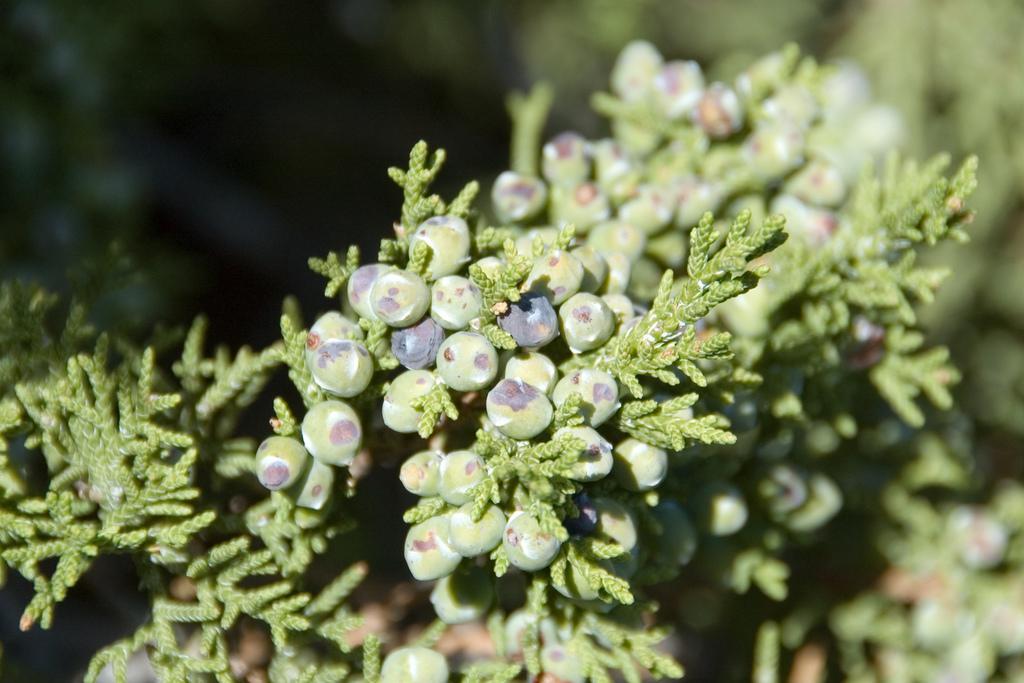Can you describe this image briefly? In this image I can see few plants which are green in color and to them I can see few fruits which are green and black in color. I can see the blurry background. 